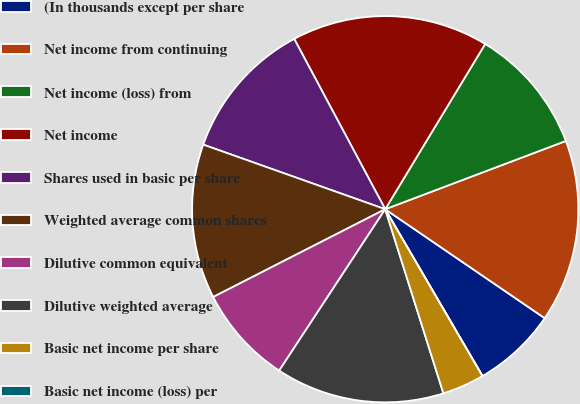Convert chart to OTSL. <chart><loc_0><loc_0><loc_500><loc_500><pie_chart><fcel>(In thousands except per share<fcel>Net income from continuing<fcel>Net income (loss) from<fcel>Net income<fcel>Shares used in basic per share<fcel>Weighted average common shares<fcel>Dilutive common equivalent<fcel>Dilutive weighted average<fcel>Basic net income per share<fcel>Basic net income (loss) per<nl><fcel>7.06%<fcel>15.29%<fcel>10.59%<fcel>16.47%<fcel>11.76%<fcel>12.94%<fcel>8.24%<fcel>14.12%<fcel>3.53%<fcel>0.0%<nl></chart> 